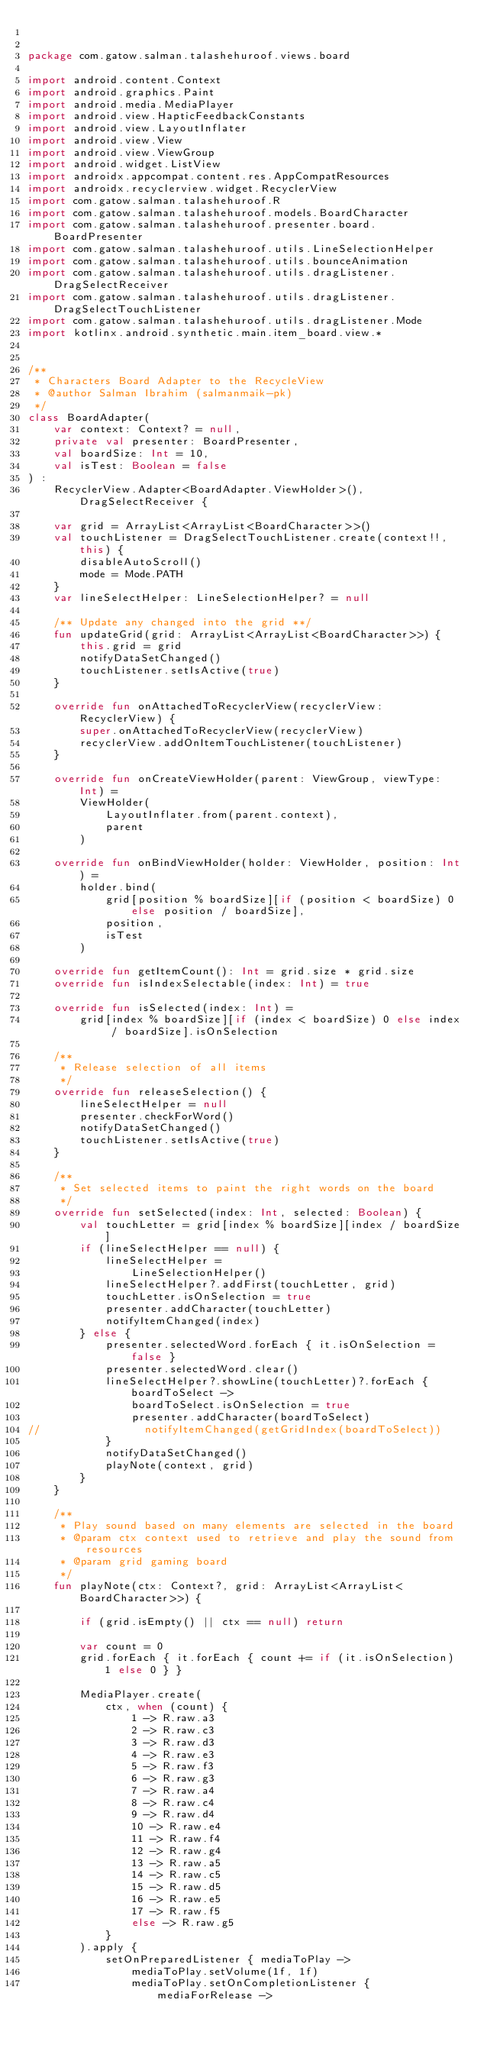Convert code to text. <code><loc_0><loc_0><loc_500><loc_500><_Kotlin_>

package com.gatow.salman.talashehuroof.views.board

import android.content.Context
import android.graphics.Paint
import android.media.MediaPlayer
import android.view.HapticFeedbackConstants
import android.view.LayoutInflater
import android.view.View
import android.view.ViewGroup
import android.widget.ListView
import androidx.appcompat.content.res.AppCompatResources
import androidx.recyclerview.widget.RecyclerView
import com.gatow.salman.talashehuroof.R
import com.gatow.salman.talashehuroof.models.BoardCharacter
import com.gatow.salman.talashehuroof.presenter.board.BoardPresenter
import com.gatow.salman.talashehuroof.utils.LineSelectionHelper
import com.gatow.salman.talashehuroof.utils.bounceAnimation
import com.gatow.salman.talashehuroof.utils.dragListener.DragSelectReceiver
import com.gatow.salman.talashehuroof.utils.dragListener.DragSelectTouchListener
import com.gatow.salman.talashehuroof.utils.dragListener.Mode
import kotlinx.android.synthetic.main.item_board.view.*


/**
 * Characters Board Adapter to the RecycleView
 * @author Salman Ibrahim (salmanmaik-pk)
 */
class BoardAdapter(
    var context: Context? = null,
    private val presenter: BoardPresenter,
    val boardSize: Int = 10,
    val isTest: Boolean = false
) :
    RecyclerView.Adapter<BoardAdapter.ViewHolder>(), DragSelectReceiver {

    var grid = ArrayList<ArrayList<BoardCharacter>>()
    val touchListener = DragSelectTouchListener.create(context!!, this) {
        disableAutoScroll()
        mode = Mode.PATH
    }
    var lineSelectHelper: LineSelectionHelper? = null

    /** Update any changed into the grid **/
    fun updateGrid(grid: ArrayList<ArrayList<BoardCharacter>>) {
        this.grid = grid
        notifyDataSetChanged()
        touchListener.setIsActive(true)
    }

    override fun onAttachedToRecyclerView(recyclerView: RecyclerView) {
        super.onAttachedToRecyclerView(recyclerView)
        recyclerView.addOnItemTouchListener(touchListener)
    }

    override fun onCreateViewHolder(parent: ViewGroup, viewType: Int) =
        ViewHolder(
            LayoutInflater.from(parent.context),
            parent
        )

    override fun onBindViewHolder(holder: ViewHolder, position: Int) =
        holder.bind(
            grid[position % boardSize][if (position < boardSize) 0 else position / boardSize],
            position,
            isTest
        )

    override fun getItemCount(): Int = grid.size * grid.size
    override fun isIndexSelectable(index: Int) = true

    override fun isSelected(index: Int) =
        grid[index % boardSize][if (index < boardSize) 0 else index / boardSize].isOnSelection

    /**
     * Release selection of all items
     */
    override fun releaseSelection() {
        lineSelectHelper = null
        presenter.checkForWord()
        notifyDataSetChanged()
        touchListener.setIsActive(true)
    }

    /**
     * Set selected items to paint the right words on the board
     */
    override fun setSelected(index: Int, selected: Boolean) {
        val touchLetter = grid[index % boardSize][index / boardSize]
        if (lineSelectHelper == null) {
            lineSelectHelper =
                LineSelectionHelper()
            lineSelectHelper?.addFirst(touchLetter, grid)
            touchLetter.isOnSelection = true
            presenter.addCharacter(touchLetter)
            notifyItemChanged(index)
        } else {
            presenter.selectedWord.forEach { it.isOnSelection = false }
            presenter.selectedWord.clear()
            lineSelectHelper?.showLine(touchLetter)?.forEach { boardToSelect ->
                boardToSelect.isOnSelection = true
                presenter.addCharacter(boardToSelect)
//                notifyItemChanged(getGridIndex(boardToSelect))
            }
            notifyDataSetChanged()
            playNote(context, grid)
        }
    }

    /**
     * Play sound based on many elements are selected in the board
     * @param ctx context used to retrieve and play the sound from resources
     * @param grid gaming board
     */
    fun playNote(ctx: Context?, grid: ArrayList<ArrayList<BoardCharacter>>) {

        if (grid.isEmpty() || ctx == null) return

        var count = 0
        grid.forEach { it.forEach { count += if (it.isOnSelection) 1 else 0 } }

        MediaPlayer.create(
            ctx, when (count) {
                1 -> R.raw.a3
                2 -> R.raw.c3
                3 -> R.raw.d3
                4 -> R.raw.e3
                5 -> R.raw.f3
                6 -> R.raw.g3
                7 -> R.raw.a4
                8 -> R.raw.c4
                9 -> R.raw.d4
                10 -> R.raw.e4
                11 -> R.raw.f4
                12 -> R.raw.g4
                13 -> R.raw.a5
                14 -> R.raw.c5
                15 -> R.raw.d5
                16 -> R.raw.e5
                17 -> R.raw.f5
                else -> R.raw.g5
            }
        ).apply {
            setOnPreparedListener { mediaToPlay ->
                mediaToPlay.setVolume(1f, 1f)
                mediaToPlay.setOnCompletionListener { mediaForRelease -></code> 